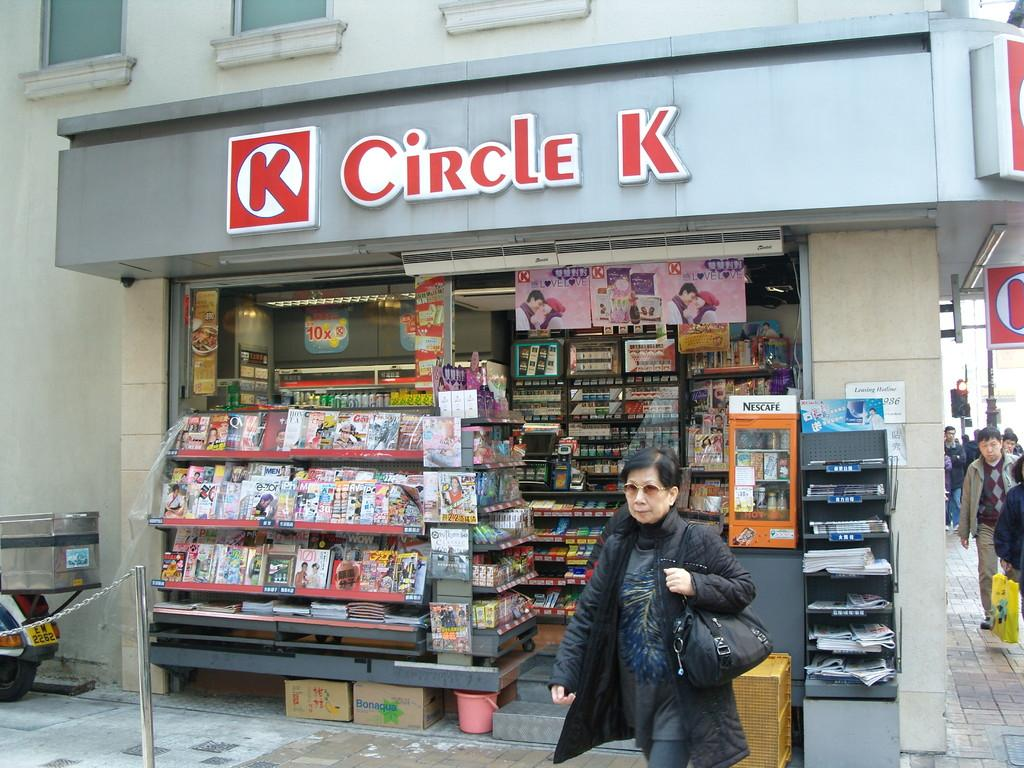Provide a one-sentence caption for the provided image. A woman in a coat walks out of a Circle K store. 